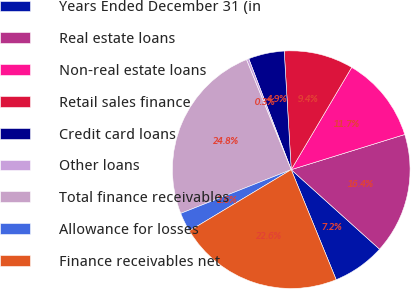Convert chart to OTSL. <chart><loc_0><loc_0><loc_500><loc_500><pie_chart><fcel>Years Ended December 31 (in<fcel>Real estate loans<fcel>Non-real estate loans<fcel>Retail sales finance<fcel>Credit card loans<fcel>Other loans<fcel>Total finance receivables<fcel>Allowance for losses<fcel>Finance receivables net<nl><fcel>7.16%<fcel>16.45%<fcel>11.72%<fcel>9.44%<fcel>4.88%<fcel>0.33%<fcel>24.85%<fcel>2.61%<fcel>22.57%<nl></chart> 